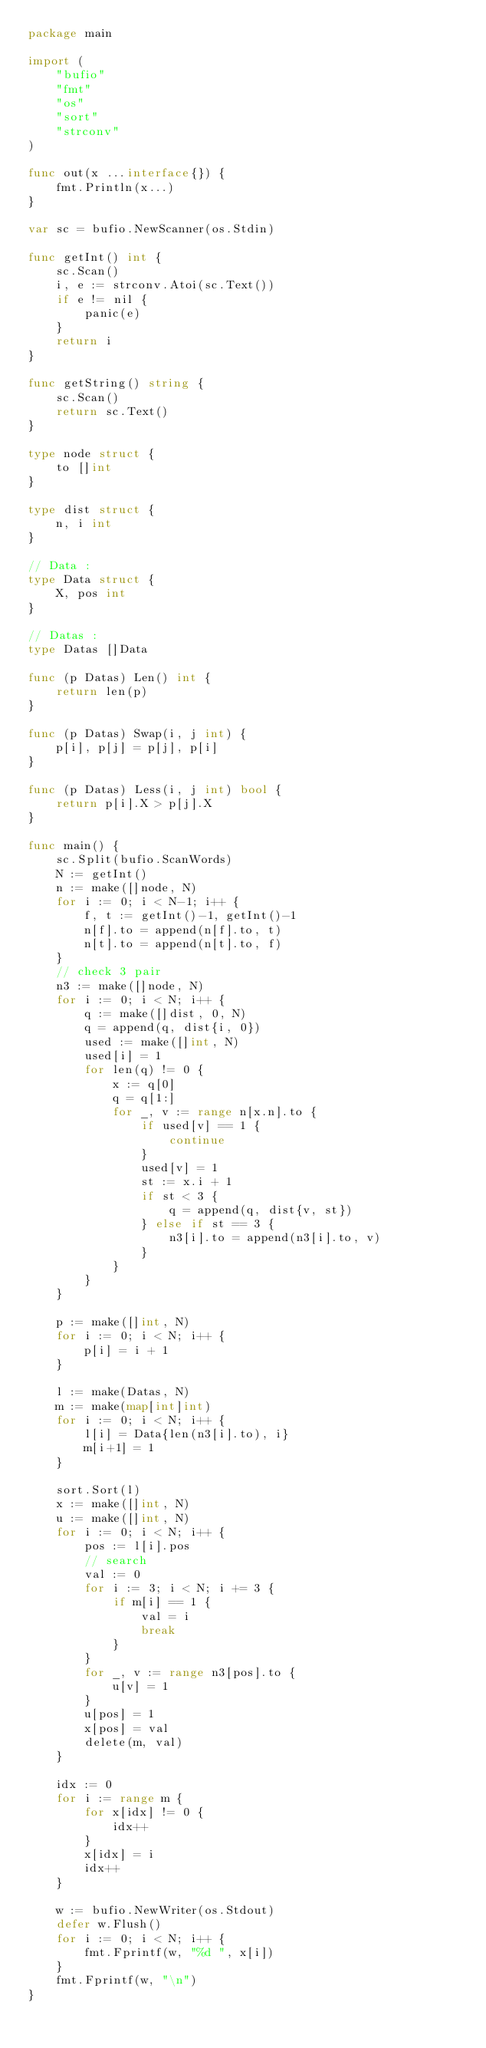<code> <loc_0><loc_0><loc_500><loc_500><_Go_>package main

import (
	"bufio"
	"fmt"
	"os"
	"sort"
	"strconv"
)

func out(x ...interface{}) {
	fmt.Println(x...)
}

var sc = bufio.NewScanner(os.Stdin)

func getInt() int {
	sc.Scan()
	i, e := strconv.Atoi(sc.Text())
	if e != nil {
		panic(e)
	}
	return i
}

func getString() string {
	sc.Scan()
	return sc.Text()
}

type node struct {
	to []int
}

type dist struct {
	n, i int
}

// Data :
type Data struct {
	X, pos int
}

// Datas :
type Datas []Data

func (p Datas) Len() int {
	return len(p)
}

func (p Datas) Swap(i, j int) {
	p[i], p[j] = p[j], p[i]
}

func (p Datas) Less(i, j int) bool {
	return p[i].X > p[j].X
}

func main() {
	sc.Split(bufio.ScanWords)
	N := getInt()
	n := make([]node, N)
	for i := 0; i < N-1; i++ {
		f, t := getInt()-1, getInt()-1
		n[f].to = append(n[f].to, t)
		n[t].to = append(n[t].to, f)
	}
	// check 3 pair
	n3 := make([]node, N)
	for i := 0; i < N; i++ {
		q := make([]dist, 0, N)
		q = append(q, dist{i, 0})
		used := make([]int, N)
		used[i] = 1
		for len(q) != 0 {
			x := q[0]
			q = q[1:]
			for _, v := range n[x.n].to {
				if used[v] == 1 {
					continue
				}
				used[v] = 1
				st := x.i + 1
				if st < 3 {
					q = append(q, dist{v, st})
				} else if st == 3 {
					n3[i].to = append(n3[i].to, v)
				}
			}
		}
	}

	p := make([]int, N)
	for i := 0; i < N; i++ {
		p[i] = i + 1
	}

	l := make(Datas, N)
	m := make(map[int]int)
	for i := 0; i < N; i++ {
		l[i] = Data{len(n3[i].to), i}
		m[i+1] = 1
	}

	sort.Sort(l)
	x := make([]int, N)
	u := make([]int, N)
	for i := 0; i < N; i++ {
		pos := l[i].pos
		// search
		val := 0
		for i := 3; i < N; i += 3 {
			if m[i] == 1 {
				val = i
				break
			}
		}
		for _, v := range n3[pos].to {
			u[v] = 1
		}
		u[pos] = 1
		x[pos] = val
		delete(m, val)
	}

	idx := 0
	for i := range m {
		for x[idx] != 0 {
			idx++
		}
		x[idx] = i
		idx++
	}

	w := bufio.NewWriter(os.Stdout)
	defer w.Flush()
	for i := 0; i < N; i++ {
		fmt.Fprintf(w, "%d ", x[i])
	}
	fmt.Fprintf(w, "\n")
}
</code> 